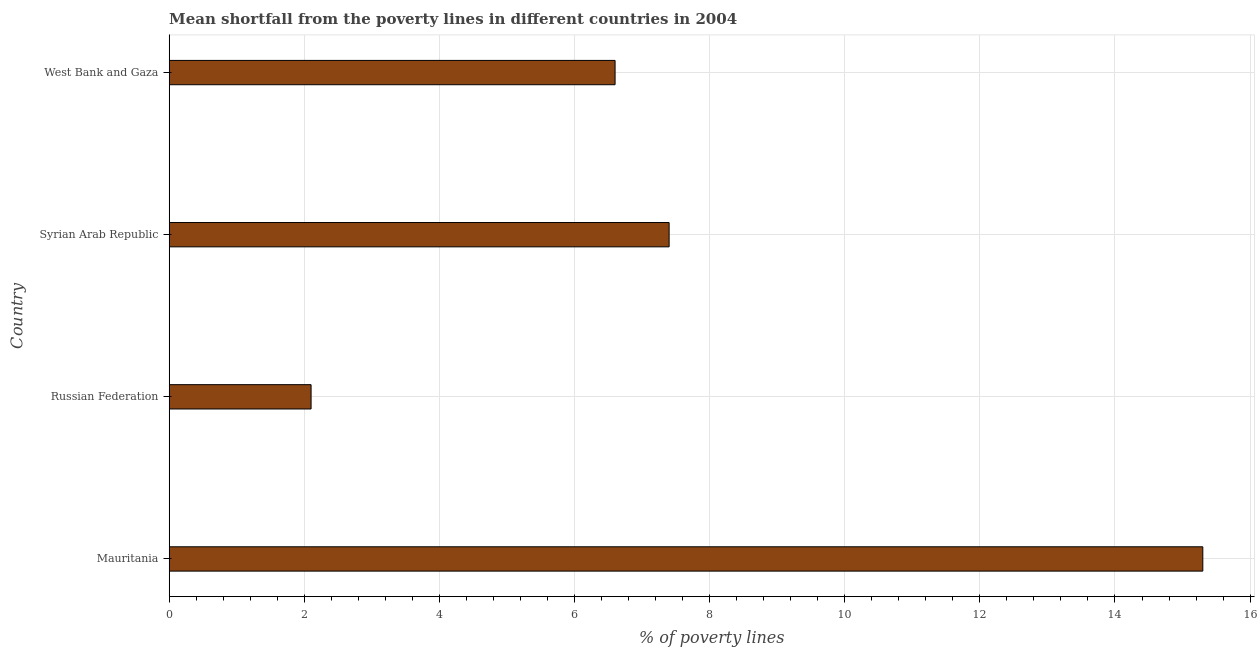Does the graph contain any zero values?
Your answer should be very brief. No. Does the graph contain grids?
Ensure brevity in your answer.  Yes. What is the title of the graph?
Provide a succinct answer. Mean shortfall from the poverty lines in different countries in 2004. What is the label or title of the X-axis?
Your answer should be compact. % of poverty lines. What is the label or title of the Y-axis?
Your answer should be compact. Country. In which country was the poverty gap at national poverty lines maximum?
Your answer should be compact. Mauritania. In which country was the poverty gap at national poverty lines minimum?
Make the answer very short. Russian Federation. What is the sum of the poverty gap at national poverty lines?
Give a very brief answer. 31.4. What is the difference between the poverty gap at national poverty lines in Russian Federation and Syrian Arab Republic?
Offer a terse response. -5.3. What is the average poverty gap at national poverty lines per country?
Keep it short and to the point. 7.85. What is the median poverty gap at national poverty lines?
Your answer should be very brief. 7. What is the ratio of the poverty gap at national poverty lines in Mauritania to that in Russian Federation?
Your response must be concise. 7.29. Is the poverty gap at national poverty lines in Russian Federation less than that in Syrian Arab Republic?
Your response must be concise. Yes. Is the difference between the poverty gap at national poverty lines in Russian Federation and West Bank and Gaza greater than the difference between any two countries?
Make the answer very short. No. What is the difference between the highest and the second highest poverty gap at national poverty lines?
Offer a terse response. 7.9. What is the difference between the highest and the lowest poverty gap at national poverty lines?
Provide a short and direct response. 13.2. Are all the bars in the graph horizontal?
Give a very brief answer. Yes. What is the difference between two consecutive major ticks on the X-axis?
Provide a succinct answer. 2. Are the values on the major ticks of X-axis written in scientific E-notation?
Keep it short and to the point. No. What is the % of poverty lines of Syrian Arab Republic?
Your response must be concise. 7.4. What is the difference between the % of poverty lines in Mauritania and Russian Federation?
Make the answer very short. 13.2. What is the difference between the % of poverty lines in Mauritania and Syrian Arab Republic?
Offer a terse response. 7.9. What is the difference between the % of poverty lines in Syrian Arab Republic and West Bank and Gaza?
Give a very brief answer. 0.8. What is the ratio of the % of poverty lines in Mauritania to that in Russian Federation?
Keep it short and to the point. 7.29. What is the ratio of the % of poverty lines in Mauritania to that in Syrian Arab Republic?
Give a very brief answer. 2.07. What is the ratio of the % of poverty lines in Mauritania to that in West Bank and Gaza?
Offer a very short reply. 2.32. What is the ratio of the % of poverty lines in Russian Federation to that in Syrian Arab Republic?
Give a very brief answer. 0.28. What is the ratio of the % of poverty lines in Russian Federation to that in West Bank and Gaza?
Offer a terse response. 0.32. What is the ratio of the % of poverty lines in Syrian Arab Republic to that in West Bank and Gaza?
Provide a succinct answer. 1.12. 